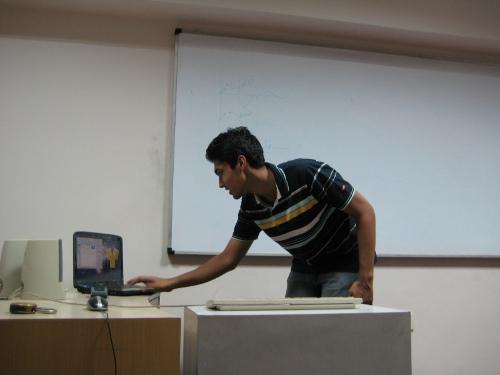What is the man looking at?
Write a very short answer. Laptop. Is he drinking wine?
Answer briefly. No. What sort of place is this?
Be succinct. Classroom. Is there a printer in the scene?
Quick response, please. No. Is the human in a hotel?
Concise answer only. No. Is the man looking at himself in the mirror?
Give a very brief answer. No. What pattern is on the man's shirt?
Concise answer only. Stripes. How many skateboards are in the picture?
Write a very short answer. 0. Where is the woman?
Be succinct. No woman. Are the people moving?
Concise answer only. No. Where is the mouse?
Concise answer only. On desk. Is that a laptop or a desktop PC?
Give a very brief answer. Laptop. What brand is the laptop?
Give a very brief answer. Apple. What is the man playing?
Concise answer only. Computer. 